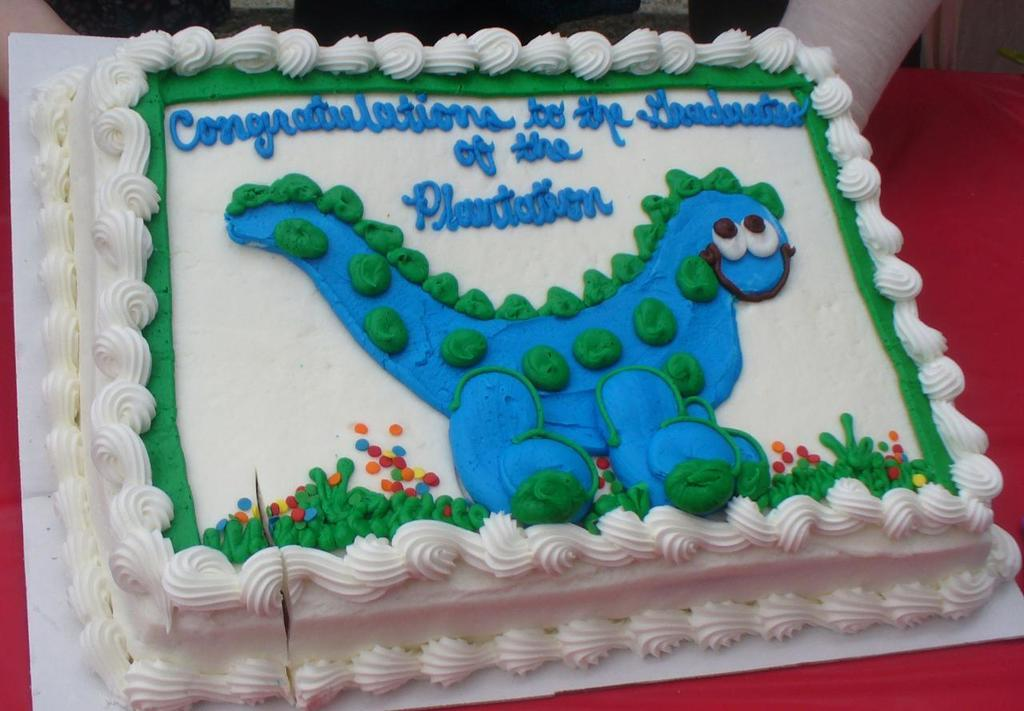What is the main subject of the image? There is a cake in the image. Can you describe the appearance of the cake? The cake has multiple colors, including white, blue, green, red, and orange. Are there any people visible in the image? Yes, there is a human visible in the image. What type of snow can be seen falling on the cake in the image? There is no snow present in the image, and therefore no snow can be seen falling on the cake. 